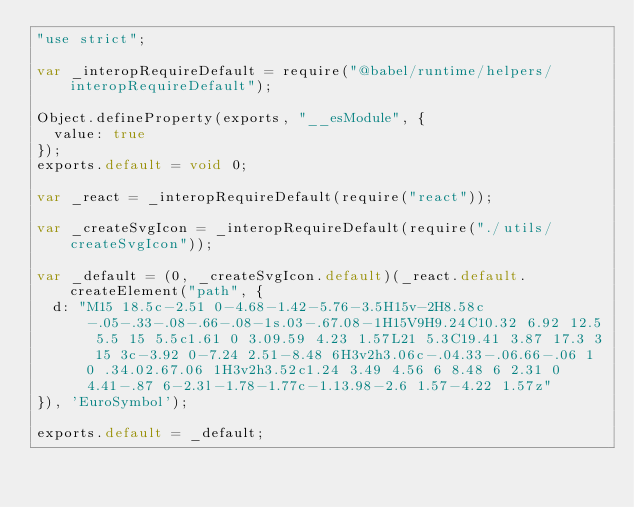<code> <loc_0><loc_0><loc_500><loc_500><_JavaScript_>"use strict";

var _interopRequireDefault = require("@babel/runtime/helpers/interopRequireDefault");

Object.defineProperty(exports, "__esModule", {
  value: true
});
exports.default = void 0;

var _react = _interopRequireDefault(require("react"));

var _createSvgIcon = _interopRequireDefault(require("./utils/createSvgIcon"));

var _default = (0, _createSvgIcon.default)(_react.default.createElement("path", {
  d: "M15 18.5c-2.51 0-4.68-1.42-5.76-3.5H15v-2H8.58c-.05-.33-.08-.66-.08-1s.03-.67.08-1H15V9H9.24C10.32 6.92 12.5 5.5 15 5.5c1.61 0 3.09.59 4.23 1.57L21 5.3C19.41 3.87 17.3 3 15 3c-3.92 0-7.24 2.51-8.48 6H3v2h3.06c-.04.33-.06.66-.06 1 0 .34.02.67.06 1H3v2h3.52c1.24 3.49 4.56 6 8.48 6 2.31 0 4.41-.87 6-2.3l-1.78-1.77c-1.13.98-2.6 1.57-4.22 1.57z"
}), 'EuroSymbol');

exports.default = _default;</code> 